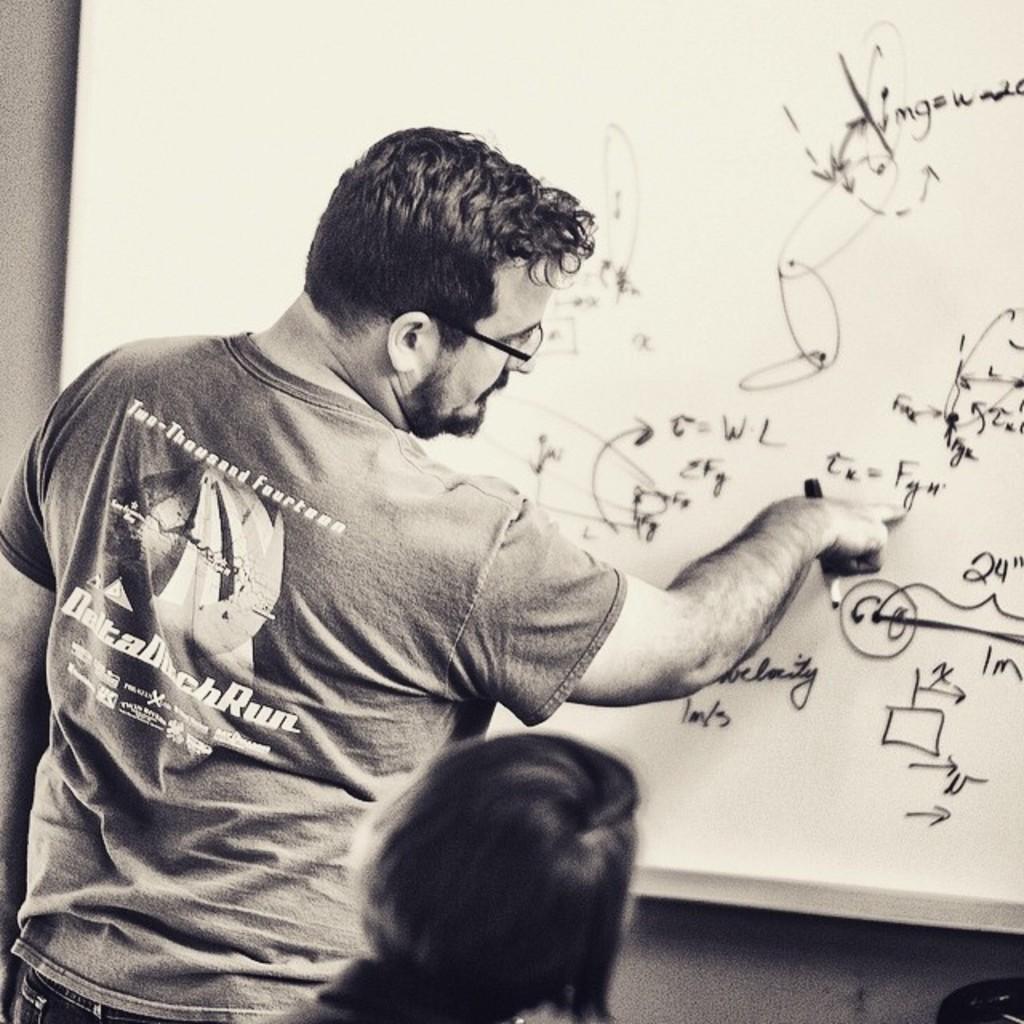What year is spelled out on the back of the man's shirt?
Ensure brevity in your answer.  2014. 